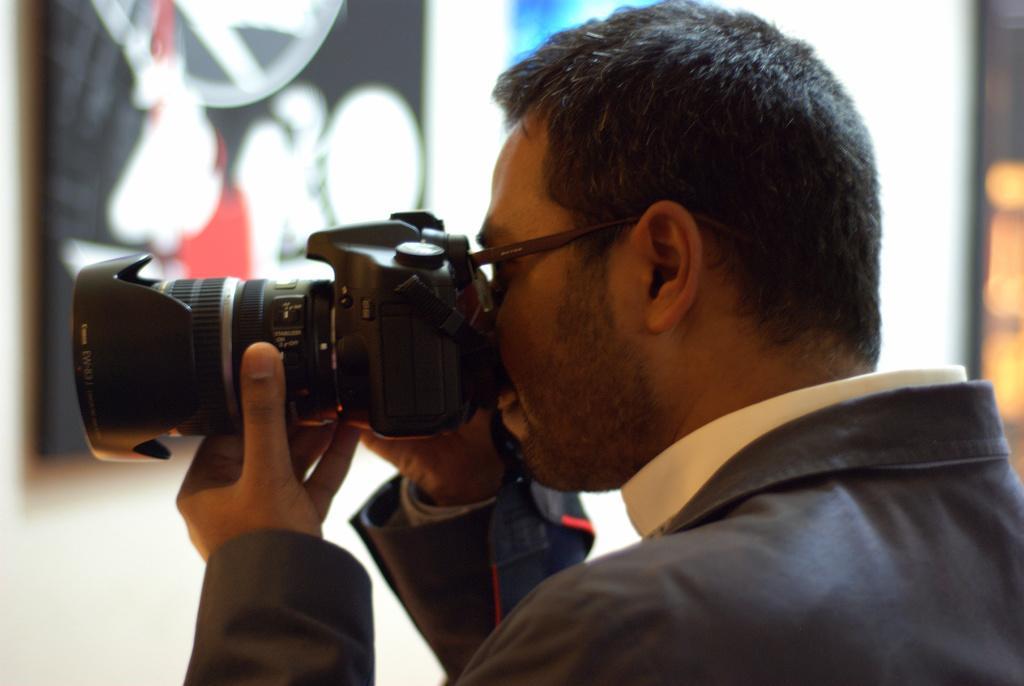Describe this image in one or two sentences. In this image we can see a person on the right side and he is clicking an image with this camera. 